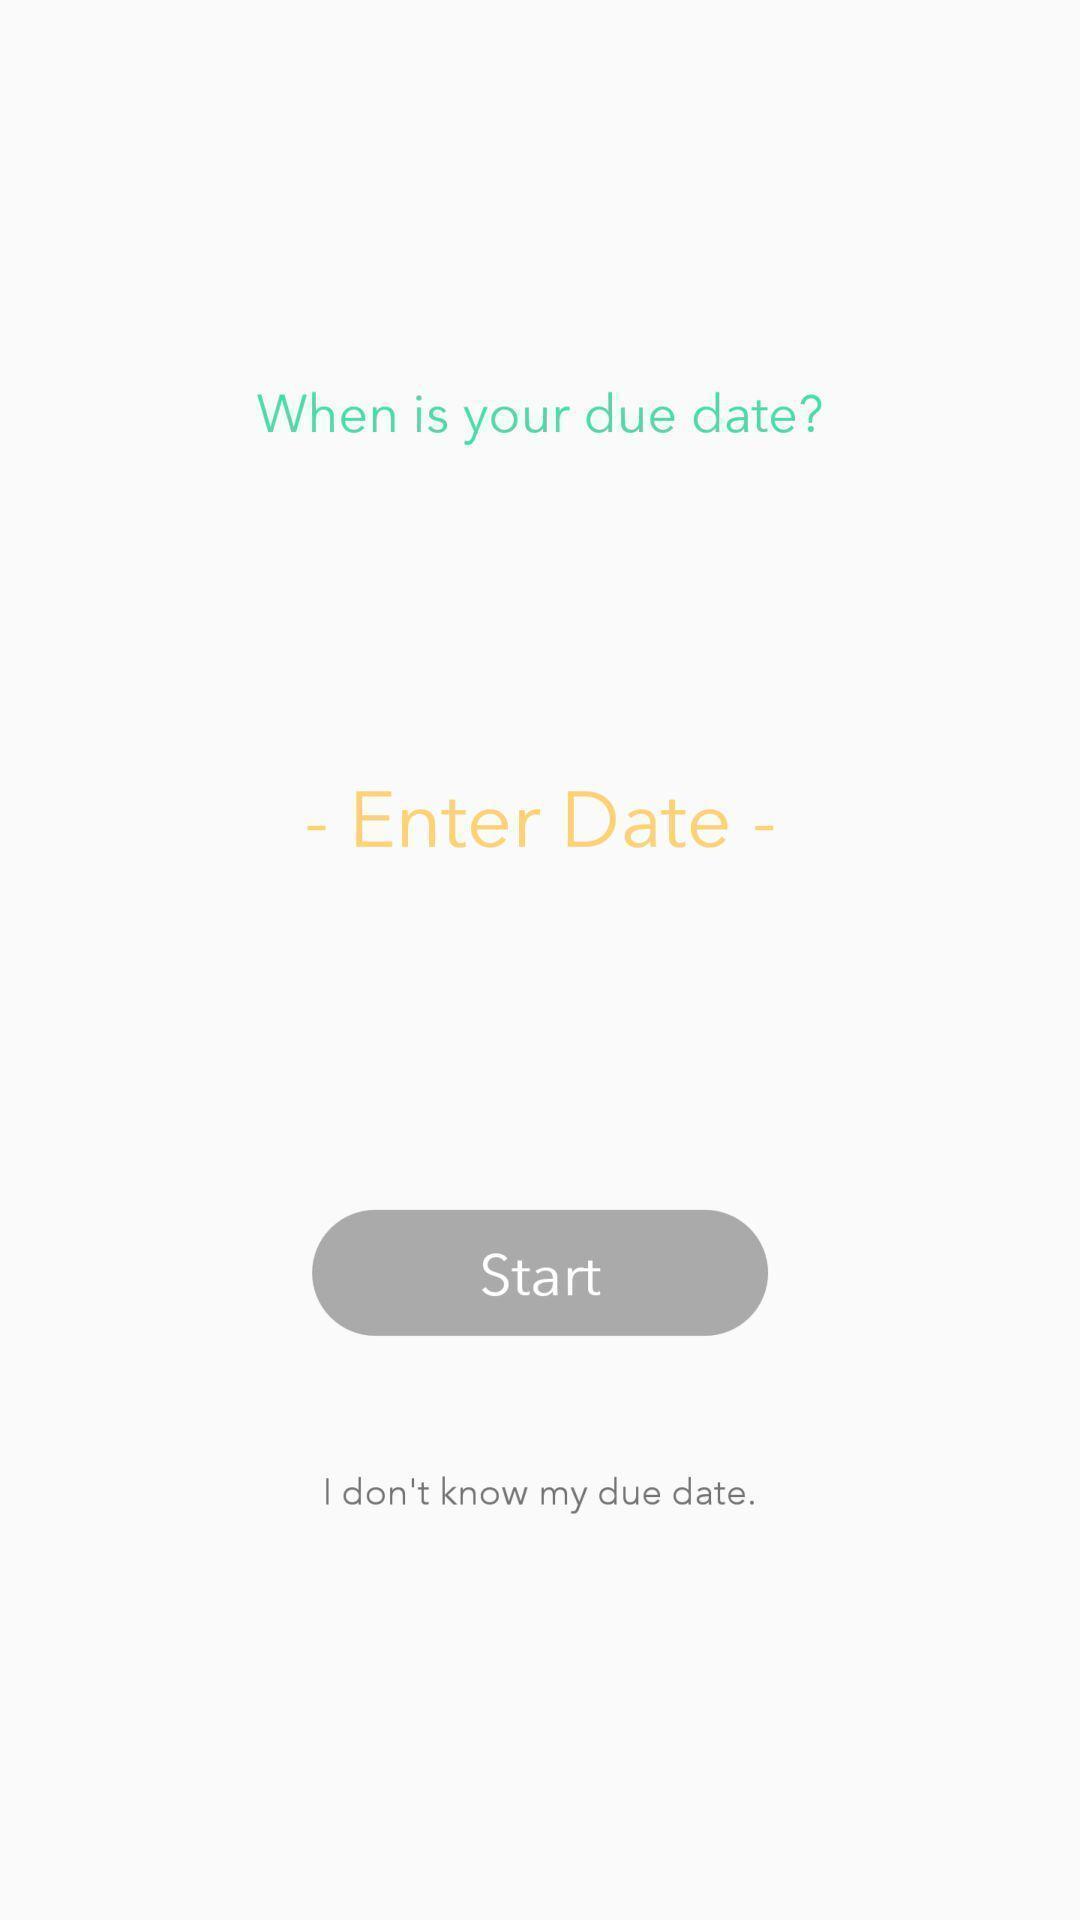Give me a summary of this screen capture. Welcome page asking to enter a date. 